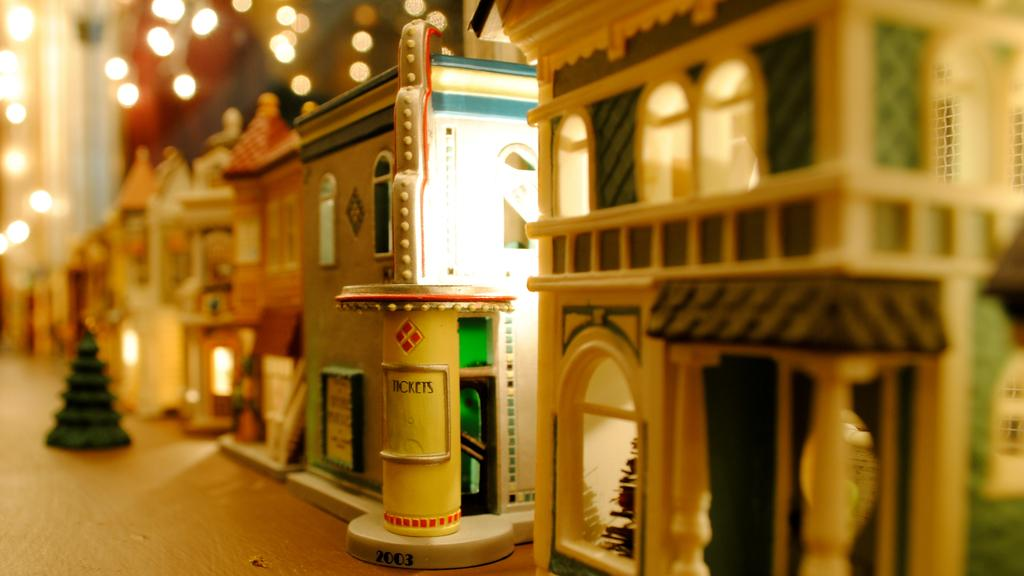What type of objects are featured in the image? There are house models in the image. How many tomatoes are placed on the butter in the image? There are no tomatoes or butter present in the image; it features house models. 